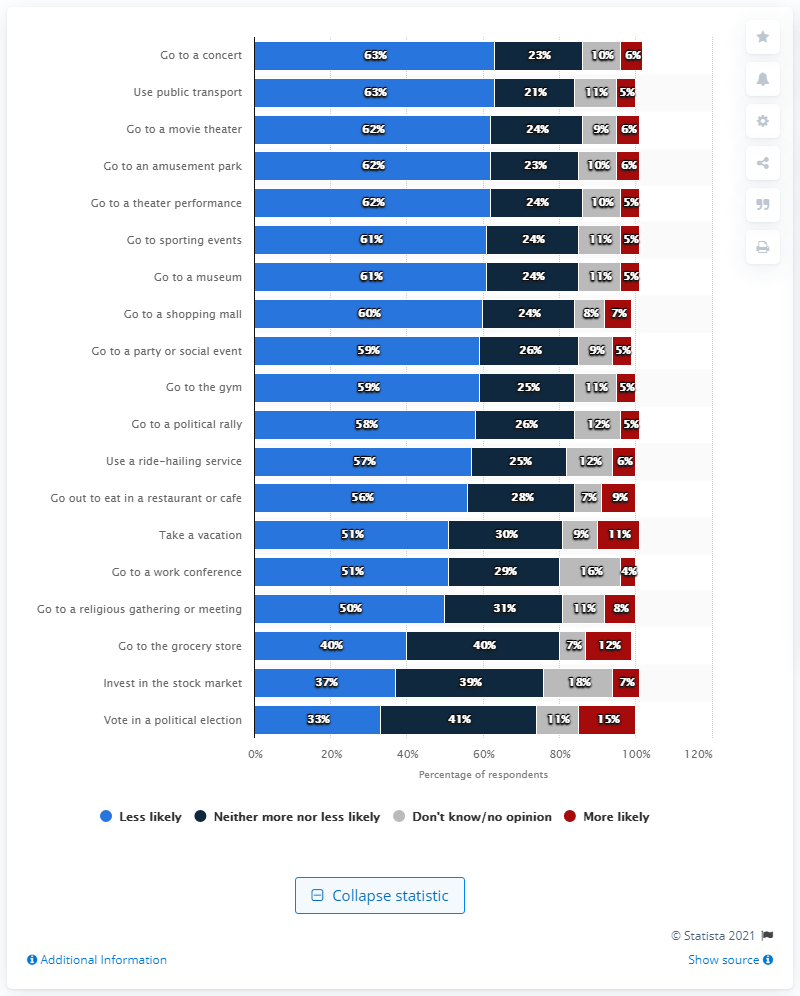Give some essential details in this illustration. There are 19 rows of bars. The modes of 'Less likely' and 'More likely' differ in their degree of likelihood. 